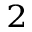<formula> <loc_0><loc_0><loc_500><loc_500>^ { 2 }</formula> 